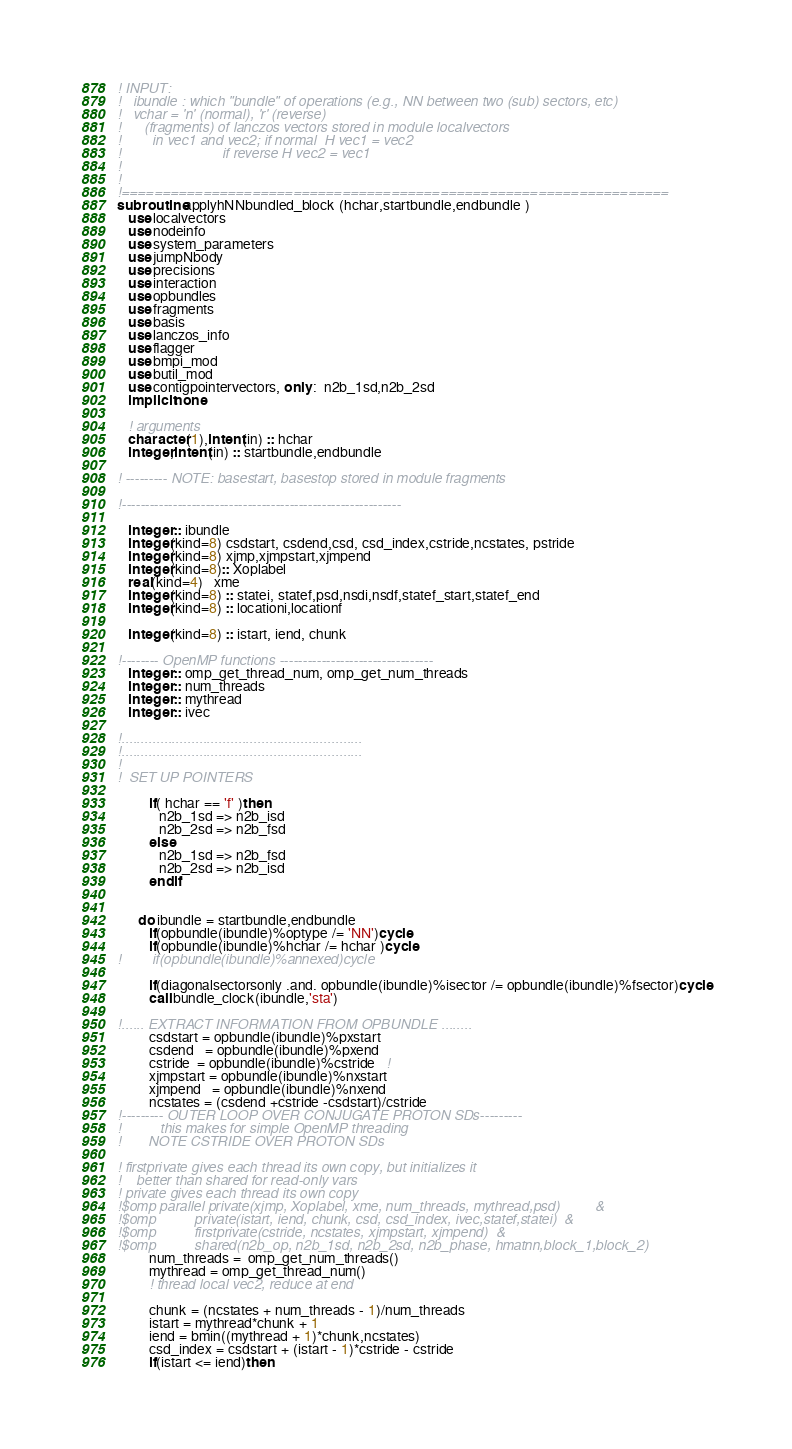Convert code to text. <code><loc_0><loc_0><loc_500><loc_500><_FORTRAN_>! INPUT:
!   ibundle : which "bundle" of operations (e.g., NN between two (sub) sectors, etc)
!   vchar = 'n' (normal), 'r' (reverse)
!      (fragments) of lanczos vectors stored in module localvectors
!        in vec1 and vec2; if normal  H vec1 = vec2
!                          if reverse H vec2 = vec1
!   
!
!===================================================================
subroutine applyhNNbundled_block (hchar,startbundle,endbundle )
   use localvectors
   use nodeinfo
   use system_parameters
   use jumpNbody
   use precisions
   use interaction
   use opbundles
   use fragments
   use basis
   use lanczos_info
   use flagger
   use bmpi_mod
   use butil_mod
   use contigpointervectors, only :  n2b_1sd,n2b_2sd
   implicit none

   ! arguments
   character(1),intent(in) :: hchar
   integer,intent(in) :: startbundle,endbundle

! --------- NOTE: basestart, basestop stored in module fragments

!------------------------------------------------------------

   integer :: ibundle
   integer(kind=8) csdstart, csdend,csd, csd_index,cstride,ncstates, pstride
   integer(kind=8) xjmp,xjmpstart,xjmpend
   integer(kind=8):: Xoplabel
   real(kind=4)   xme
   integer(kind=8) :: statei, statef,psd,nsdi,nsdf,statef_start,statef_end
   integer(kind=8) :: locationi,locationf
   
   integer(kind=8) :: istart, iend, chunk

!-------- OpenMP functions ---------------------------------
   integer :: omp_get_thread_num, omp_get_num_threads
   integer :: num_threads
   integer :: mythread
   integer :: ivec

!..............................................................
!..............................................................
!
!  SET UP POINTERS

         if( hchar == 'f' )then
            n2b_1sd => n2b_isd
            n2b_2sd => n2b_fsd
         else
            n2b_1sd => n2b_fsd
            n2b_2sd => n2b_isd
         endif


      do ibundle = startbundle,endbundle
         if(opbundle(ibundle)%optype /= 'NN')cycle
         if(opbundle(ibundle)%hchar /= hchar )cycle
!		 if(opbundle(ibundle)%annexed)cycle
		 
         if(diagonalsectorsonly .and. opbundle(ibundle)%isector /= opbundle(ibundle)%fsector)cycle
	     call bundle_clock(ibundle,'sta')
		 
!...... EXTRACT INFORMATION FROM OPBUNDLE ........
         csdstart = opbundle(ibundle)%pxstart
         csdend   = opbundle(ibundle)%pxend
         cstride  = opbundle(ibundle)%cstride   !
         xjmpstart = opbundle(ibundle)%nxstart
         xjmpend   = opbundle(ibundle)%nxend
         ncstates = (csdend +cstride -csdstart)/cstride
!--------- OUTER LOOP OVER CONJUGATE PROTON SDs---------
!          this makes for simple OpenMP threading
!       NOTE CSTRIDE OVER PROTON SDs 

! firstprivate gives each thread its own copy, but initializes it
!    better than shared for read-only vars
! private gives each thread its own copy
!$omp parallel private(xjmp, Xoplabel, xme, num_threads, mythread,psd)         &
!$omp          private(istart, iend, chunk, csd, csd_index, ivec,statef,statei)  &
!$omp          firstprivate(cstride, ncstates, xjmpstart, xjmpend)  &
!$omp          shared(n2b_op, n2b_1sd, n2b_2sd, n2b_phase, hmatnn,block_1,block_2)
         num_threads =  omp_get_num_threads()
         mythread = omp_get_thread_num()
         ! thread local vec2, reduce at end

         chunk = (ncstates + num_threads - 1)/num_threads
         istart = mythread*chunk + 1
         iend = bmin((mythread + 1)*chunk,ncstates)
         csd_index = csdstart + (istart - 1)*cstride - cstride
         if(istart <= iend)then
</code> 